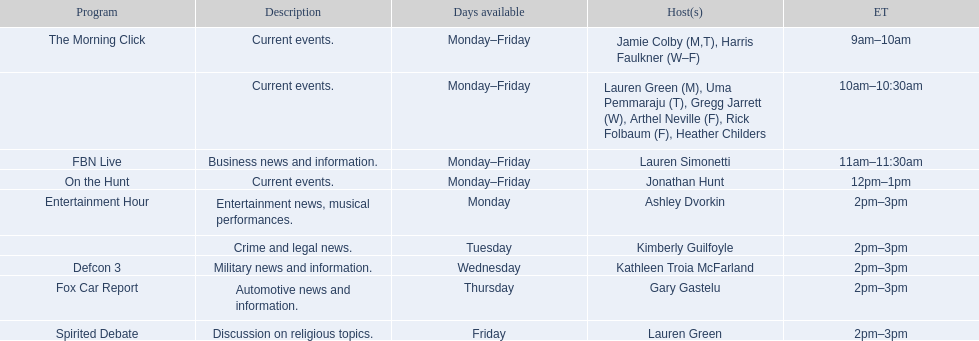What is the first show to play on monday mornings? The Morning Click. 